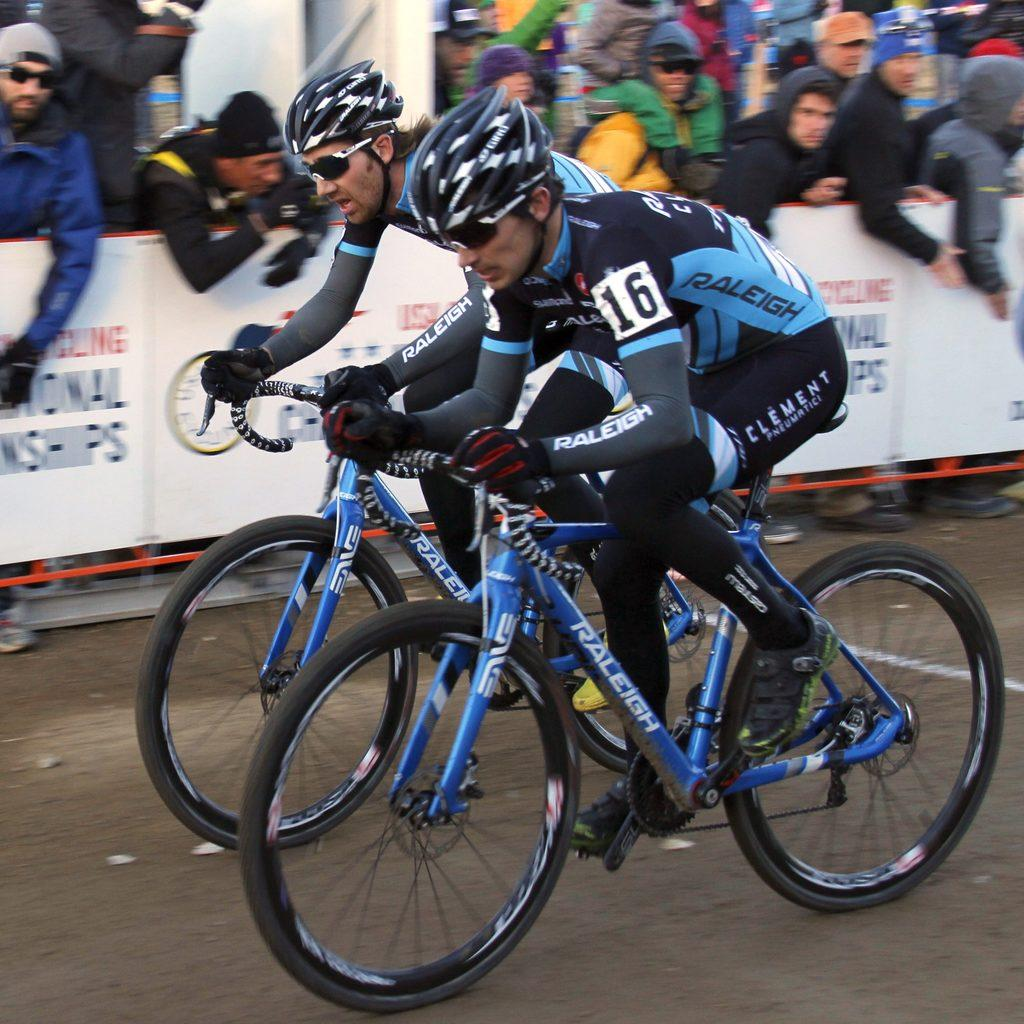How many persons are in the image? There are two persons in the image. What are the persons wearing on their heads? Both persons are wearing helmets. What else are the persons wearing? Both persons are wearing gloves. What are the persons doing in the image? The persons are riding cycles. What can be seen in the background of the image? There are banners in the background. How many people are present in the image? There are many people in the image. What accessories are some people wearing? Some people are wearing caps and goggles. What type of board is being used by the persons in the image? There is no board present in the image; the persons are riding cycles. Can you see any fangs on the persons in the image? There are no fangs visible on the persons in the image. 